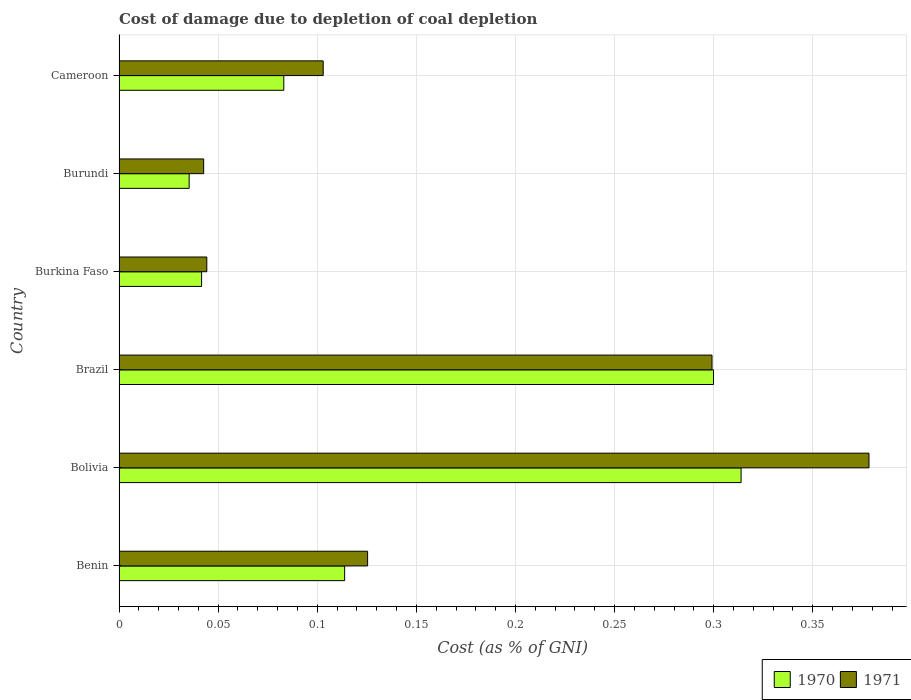How many different coloured bars are there?
Your response must be concise. 2. How many groups of bars are there?
Keep it short and to the point. 6. Are the number of bars on each tick of the Y-axis equal?
Provide a succinct answer. Yes. How many bars are there on the 6th tick from the top?
Ensure brevity in your answer.  2. How many bars are there on the 5th tick from the bottom?
Keep it short and to the point. 2. What is the label of the 6th group of bars from the top?
Provide a succinct answer. Benin. What is the cost of damage caused due to coal depletion in 1971 in Burundi?
Your answer should be very brief. 0.04. Across all countries, what is the maximum cost of damage caused due to coal depletion in 1971?
Give a very brief answer. 0.38. Across all countries, what is the minimum cost of damage caused due to coal depletion in 1970?
Make the answer very short. 0.04. In which country was the cost of damage caused due to coal depletion in 1971 maximum?
Keep it short and to the point. Bolivia. In which country was the cost of damage caused due to coal depletion in 1971 minimum?
Offer a very short reply. Burundi. What is the total cost of damage caused due to coal depletion in 1971 in the graph?
Make the answer very short. 0.99. What is the difference between the cost of damage caused due to coal depletion in 1970 in Burkina Faso and that in Cameroon?
Offer a terse response. -0.04. What is the difference between the cost of damage caused due to coal depletion in 1971 in Burundi and the cost of damage caused due to coal depletion in 1970 in Bolivia?
Provide a short and direct response. -0.27. What is the average cost of damage caused due to coal depletion in 1971 per country?
Offer a terse response. 0.17. What is the difference between the cost of damage caused due to coal depletion in 1971 and cost of damage caused due to coal depletion in 1970 in Burkina Faso?
Provide a succinct answer. 0. In how many countries, is the cost of damage caused due to coal depletion in 1971 greater than 0.14 %?
Ensure brevity in your answer.  2. What is the ratio of the cost of damage caused due to coal depletion in 1971 in Benin to that in Bolivia?
Ensure brevity in your answer.  0.33. Is the difference between the cost of damage caused due to coal depletion in 1971 in Burkina Faso and Burundi greater than the difference between the cost of damage caused due to coal depletion in 1970 in Burkina Faso and Burundi?
Your answer should be very brief. No. What is the difference between the highest and the second highest cost of damage caused due to coal depletion in 1971?
Offer a terse response. 0.08. What is the difference between the highest and the lowest cost of damage caused due to coal depletion in 1971?
Provide a short and direct response. 0.34. What does the 1st bar from the bottom in Burkina Faso represents?
Ensure brevity in your answer.  1970. Are all the bars in the graph horizontal?
Make the answer very short. Yes. How many countries are there in the graph?
Provide a succinct answer. 6. What is the difference between two consecutive major ticks on the X-axis?
Keep it short and to the point. 0.05. Are the values on the major ticks of X-axis written in scientific E-notation?
Your response must be concise. No. Does the graph contain any zero values?
Give a very brief answer. No. Does the graph contain grids?
Give a very brief answer. Yes. How many legend labels are there?
Offer a terse response. 2. How are the legend labels stacked?
Your answer should be very brief. Horizontal. What is the title of the graph?
Provide a succinct answer. Cost of damage due to depletion of coal depletion. What is the label or title of the X-axis?
Give a very brief answer. Cost (as % of GNI). What is the Cost (as % of GNI) in 1970 in Benin?
Provide a short and direct response. 0.11. What is the Cost (as % of GNI) of 1971 in Benin?
Ensure brevity in your answer.  0.13. What is the Cost (as % of GNI) of 1970 in Bolivia?
Make the answer very short. 0.31. What is the Cost (as % of GNI) of 1971 in Bolivia?
Offer a terse response. 0.38. What is the Cost (as % of GNI) in 1970 in Brazil?
Make the answer very short. 0.3. What is the Cost (as % of GNI) in 1971 in Brazil?
Your answer should be compact. 0.3. What is the Cost (as % of GNI) of 1970 in Burkina Faso?
Ensure brevity in your answer.  0.04. What is the Cost (as % of GNI) of 1971 in Burkina Faso?
Your answer should be very brief. 0.04. What is the Cost (as % of GNI) of 1970 in Burundi?
Your answer should be very brief. 0.04. What is the Cost (as % of GNI) in 1971 in Burundi?
Keep it short and to the point. 0.04. What is the Cost (as % of GNI) in 1970 in Cameroon?
Keep it short and to the point. 0.08. What is the Cost (as % of GNI) in 1971 in Cameroon?
Keep it short and to the point. 0.1. Across all countries, what is the maximum Cost (as % of GNI) of 1970?
Provide a succinct answer. 0.31. Across all countries, what is the maximum Cost (as % of GNI) in 1971?
Offer a very short reply. 0.38. Across all countries, what is the minimum Cost (as % of GNI) of 1970?
Your answer should be very brief. 0.04. Across all countries, what is the minimum Cost (as % of GNI) of 1971?
Keep it short and to the point. 0.04. What is the total Cost (as % of GNI) of 1970 in the graph?
Keep it short and to the point. 0.89. What is the difference between the Cost (as % of GNI) of 1970 in Benin and that in Bolivia?
Your answer should be very brief. -0.2. What is the difference between the Cost (as % of GNI) of 1971 in Benin and that in Bolivia?
Make the answer very short. -0.25. What is the difference between the Cost (as % of GNI) in 1970 in Benin and that in Brazil?
Provide a succinct answer. -0.19. What is the difference between the Cost (as % of GNI) in 1971 in Benin and that in Brazil?
Your answer should be compact. -0.17. What is the difference between the Cost (as % of GNI) of 1970 in Benin and that in Burkina Faso?
Provide a short and direct response. 0.07. What is the difference between the Cost (as % of GNI) of 1971 in Benin and that in Burkina Faso?
Your answer should be compact. 0.08. What is the difference between the Cost (as % of GNI) in 1970 in Benin and that in Burundi?
Give a very brief answer. 0.08. What is the difference between the Cost (as % of GNI) of 1971 in Benin and that in Burundi?
Make the answer very short. 0.08. What is the difference between the Cost (as % of GNI) in 1970 in Benin and that in Cameroon?
Provide a short and direct response. 0.03. What is the difference between the Cost (as % of GNI) in 1971 in Benin and that in Cameroon?
Offer a terse response. 0.02. What is the difference between the Cost (as % of GNI) of 1970 in Bolivia and that in Brazil?
Your answer should be compact. 0.01. What is the difference between the Cost (as % of GNI) of 1971 in Bolivia and that in Brazil?
Keep it short and to the point. 0.08. What is the difference between the Cost (as % of GNI) in 1970 in Bolivia and that in Burkina Faso?
Provide a succinct answer. 0.27. What is the difference between the Cost (as % of GNI) of 1971 in Bolivia and that in Burkina Faso?
Your response must be concise. 0.33. What is the difference between the Cost (as % of GNI) of 1970 in Bolivia and that in Burundi?
Provide a succinct answer. 0.28. What is the difference between the Cost (as % of GNI) of 1971 in Bolivia and that in Burundi?
Your response must be concise. 0.34. What is the difference between the Cost (as % of GNI) in 1970 in Bolivia and that in Cameroon?
Your answer should be compact. 0.23. What is the difference between the Cost (as % of GNI) of 1971 in Bolivia and that in Cameroon?
Keep it short and to the point. 0.28. What is the difference between the Cost (as % of GNI) in 1970 in Brazil and that in Burkina Faso?
Offer a terse response. 0.26. What is the difference between the Cost (as % of GNI) of 1971 in Brazil and that in Burkina Faso?
Give a very brief answer. 0.25. What is the difference between the Cost (as % of GNI) in 1970 in Brazil and that in Burundi?
Give a very brief answer. 0.26. What is the difference between the Cost (as % of GNI) in 1971 in Brazil and that in Burundi?
Provide a short and direct response. 0.26. What is the difference between the Cost (as % of GNI) in 1970 in Brazil and that in Cameroon?
Make the answer very short. 0.22. What is the difference between the Cost (as % of GNI) of 1971 in Brazil and that in Cameroon?
Provide a succinct answer. 0.2. What is the difference between the Cost (as % of GNI) of 1970 in Burkina Faso and that in Burundi?
Make the answer very short. 0.01. What is the difference between the Cost (as % of GNI) of 1971 in Burkina Faso and that in Burundi?
Give a very brief answer. 0. What is the difference between the Cost (as % of GNI) in 1970 in Burkina Faso and that in Cameroon?
Make the answer very short. -0.04. What is the difference between the Cost (as % of GNI) in 1971 in Burkina Faso and that in Cameroon?
Provide a short and direct response. -0.06. What is the difference between the Cost (as % of GNI) in 1970 in Burundi and that in Cameroon?
Your answer should be very brief. -0.05. What is the difference between the Cost (as % of GNI) in 1971 in Burundi and that in Cameroon?
Ensure brevity in your answer.  -0.06. What is the difference between the Cost (as % of GNI) of 1970 in Benin and the Cost (as % of GNI) of 1971 in Bolivia?
Make the answer very short. -0.26. What is the difference between the Cost (as % of GNI) in 1970 in Benin and the Cost (as % of GNI) in 1971 in Brazil?
Provide a succinct answer. -0.19. What is the difference between the Cost (as % of GNI) in 1970 in Benin and the Cost (as % of GNI) in 1971 in Burkina Faso?
Your answer should be compact. 0.07. What is the difference between the Cost (as % of GNI) of 1970 in Benin and the Cost (as % of GNI) of 1971 in Burundi?
Offer a very short reply. 0.07. What is the difference between the Cost (as % of GNI) in 1970 in Benin and the Cost (as % of GNI) in 1971 in Cameroon?
Provide a succinct answer. 0.01. What is the difference between the Cost (as % of GNI) of 1970 in Bolivia and the Cost (as % of GNI) of 1971 in Brazil?
Offer a very short reply. 0.01. What is the difference between the Cost (as % of GNI) of 1970 in Bolivia and the Cost (as % of GNI) of 1971 in Burkina Faso?
Your answer should be compact. 0.27. What is the difference between the Cost (as % of GNI) of 1970 in Bolivia and the Cost (as % of GNI) of 1971 in Burundi?
Your response must be concise. 0.27. What is the difference between the Cost (as % of GNI) of 1970 in Bolivia and the Cost (as % of GNI) of 1971 in Cameroon?
Ensure brevity in your answer.  0.21. What is the difference between the Cost (as % of GNI) of 1970 in Brazil and the Cost (as % of GNI) of 1971 in Burkina Faso?
Offer a very short reply. 0.26. What is the difference between the Cost (as % of GNI) in 1970 in Brazil and the Cost (as % of GNI) in 1971 in Burundi?
Your answer should be compact. 0.26. What is the difference between the Cost (as % of GNI) in 1970 in Brazil and the Cost (as % of GNI) in 1971 in Cameroon?
Ensure brevity in your answer.  0.2. What is the difference between the Cost (as % of GNI) in 1970 in Burkina Faso and the Cost (as % of GNI) in 1971 in Burundi?
Provide a short and direct response. -0. What is the difference between the Cost (as % of GNI) of 1970 in Burkina Faso and the Cost (as % of GNI) of 1971 in Cameroon?
Make the answer very short. -0.06. What is the difference between the Cost (as % of GNI) of 1970 in Burundi and the Cost (as % of GNI) of 1971 in Cameroon?
Your answer should be very brief. -0.07. What is the average Cost (as % of GNI) of 1970 per country?
Make the answer very short. 0.15. What is the average Cost (as % of GNI) in 1971 per country?
Provide a short and direct response. 0.17. What is the difference between the Cost (as % of GNI) in 1970 and Cost (as % of GNI) in 1971 in Benin?
Provide a succinct answer. -0.01. What is the difference between the Cost (as % of GNI) of 1970 and Cost (as % of GNI) of 1971 in Bolivia?
Offer a very short reply. -0.06. What is the difference between the Cost (as % of GNI) in 1970 and Cost (as % of GNI) in 1971 in Brazil?
Give a very brief answer. 0. What is the difference between the Cost (as % of GNI) in 1970 and Cost (as % of GNI) in 1971 in Burkina Faso?
Keep it short and to the point. -0. What is the difference between the Cost (as % of GNI) of 1970 and Cost (as % of GNI) of 1971 in Burundi?
Provide a short and direct response. -0.01. What is the difference between the Cost (as % of GNI) of 1970 and Cost (as % of GNI) of 1971 in Cameroon?
Offer a very short reply. -0.02. What is the ratio of the Cost (as % of GNI) of 1970 in Benin to that in Bolivia?
Provide a short and direct response. 0.36. What is the ratio of the Cost (as % of GNI) of 1971 in Benin to that in Bolivia?
Give a very brief answer. 0.33. What is the ratio of the Cost (as % of GNI) of 1970 in Benin to that in Brazil?
Keep it short and to the point. 0.38. What is the ratio of the Cost (as % of GNI) in 1971 in Benin to that in Brazil?
Provide a short and direct response. 0.42. What is the ratio of the Cost (as % of GNI) of 1970 in Benin to that in Burkina Faso?
Your answer should be compact. 2.73. What is the ratio of the Cost (as % of GNI) in 1971 in Benin to that in Burkina Faso?
Make the answer very short. 2.83. What is the ratio of the Cost (as % of GNI) in 1970 in Benin to that in Burundi?
Your answer should be very brief. 3.22. What is the ratio of the Cost (as % of GNI) of 1971 in Benin to that in Burundi?
Keep it short and to the point. 2.94. What is the ratio of the Cost (as % of GNI) in 1970 in Benin to that in Cameroon?
Make the answer very short. 1.37. What is the ratio of the Cost (as % of GNI) in 1971 in Benin to that in Cameroon?
Provide a short and direct response. 1.22. What is the ratio of the Cost (as % of GNI) in 1970 in Bolivia to that in Brazil?
Provide a short and direct response. 1.05. What is the ratio of the Cost (as % of GNI) of 1971 in Bolivia to that in Brazil?
Your answer should be compact. 1.26. What is the ratio of the Cost (as % of GNI) in 1970 in Bolivia to that in Burkina Faso?
Ensure brevity in your answer.  7.54. What is the ratio of the Cost (as % of GNI) in 1971 in Bolivia to that in Burkina Faso?
Keep it short and to the point. 8.55. What is the ratio of the Cost (as % of GNI) of 1970 in Bolivia to that in Burundi?
Make the answer very short. 8.87. What is the ratio of the Cost (as % of GNI) of 1971 in Bolivia to that in Burundi?
Your response must be concise. 8.86. What is the ratio of the Cost (as % of GNI) in 1970 in Bolivia to that in Cameroon?
Your answer should be compact. 3.78. What is the ratio of the Cost (as % of GNI) in 1971 in Bolivia to that in Cameroon?
Make the answer very short. 3.67. What is the ratio of the Cost (as % of GNI) of 1970 in Brazil to that in Burkina Faso?
Make the answer very short. 7.2. What is the ratio of the Cost (as % of GNI) in 1971 in Brazil to that in Burkina Faso?
Your response must be concise. 6.76. What is the ratio of the Cost (as % of GNI) of 1970 in Brazil to that in Burundi?
Your answer should be compact. 8.48. What is the ratio of the Cost (as % of GNI) of 1971 in Brazil to that in Burundi?
Offer a terse response. 7.01. What is the ratio of the Cost (as % of GNI) in 1970 in Brazil to that in Cameroon?
Give a very brief answer. 3.61. What is the ratio of the Cost (as % of GNI) in 1971 in Brazil to that in Cameroon?
Offer a terse response. 2.9. What is the ratio of the Cost (as % of GNI) of 1970 in Burkina Faso to that in Burundi?
Your answer should be very brief. 1.18. What is the ratio of the Cost (as % of GNI) in 1971 in Burkina Faso to that in Burundi?
Keep it short and to the point. 1.04. What is the ratio of the Cost (as % of GNI) of 1970 in Burkina Faso to that in Cameroon?
Offer a very short reply. 0.5. What is the ratio of the Cost (as % of GNI) in 1971 in Burkina Faso to that in Cameroon?
Your answer should be compact. 0.43. What is the ratio of the Cost (as % of GNI) of 1970 in Burundi to that in Cameroon?
Your response must be concise. 0.43. What is the ratio of the Cost (as % of GNI) of 1971 in Burundi to that in Cameroon?
Provide a succinct answer. 0.41. What is the difference between the highest and the second highest Cost (as % of GNI) of 1970?
Your answer should be very brief. 0.01. What is the difference between the highest and the second highest Cost (as % of GNI) of 1971?
Offer a terse response. 0.08. What is the difference between the highest and the lowest Cost (as % of GNI) in 1970?
Your response must be concise. 0.28. What is the difference between the highest and the lowest Cost (as % of GNI) in 1971?
Provide a short and direct response. 0.34. 